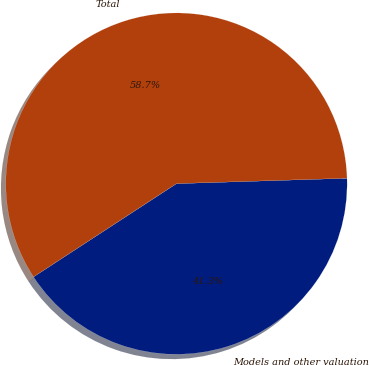<chart> <loc_0><loc_0><loc_500><loc_500><pie_chart><fcel>Models and other valuation<fcel>Total<nl><fcel>41.3%<fcel>58.7%<nl></chart> 